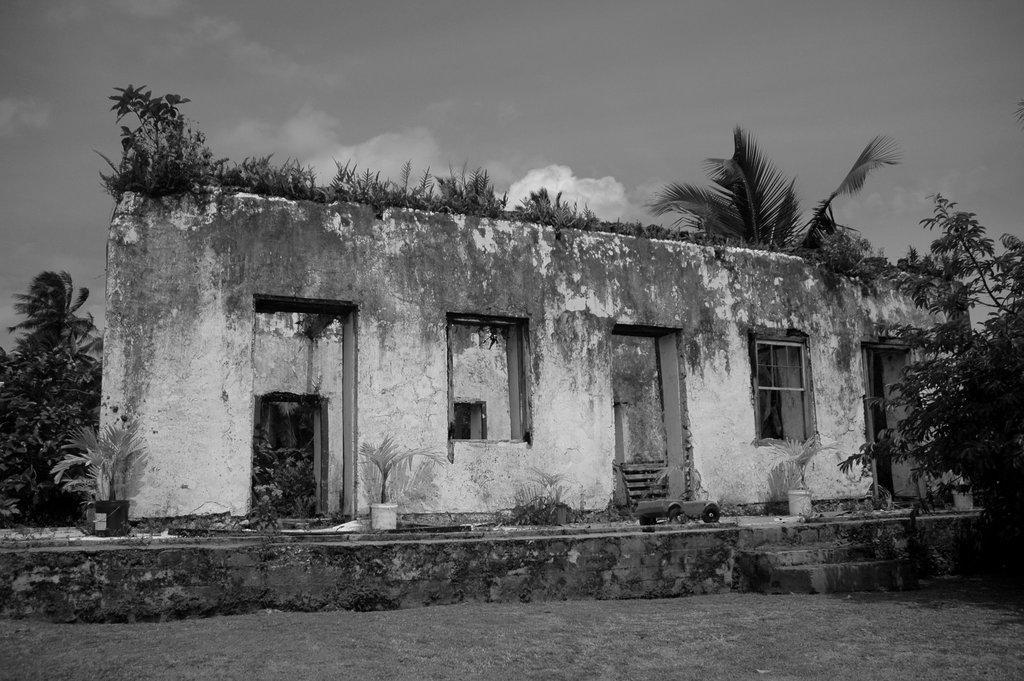Describe this image in one or two sentences. This is a black and white image. At the bottom of this image, there is grass on the ground. In the background, there are three potted plants. Beside them, there is a building having windows and without roof and doors, there are trees and there are clouds in the sky. 